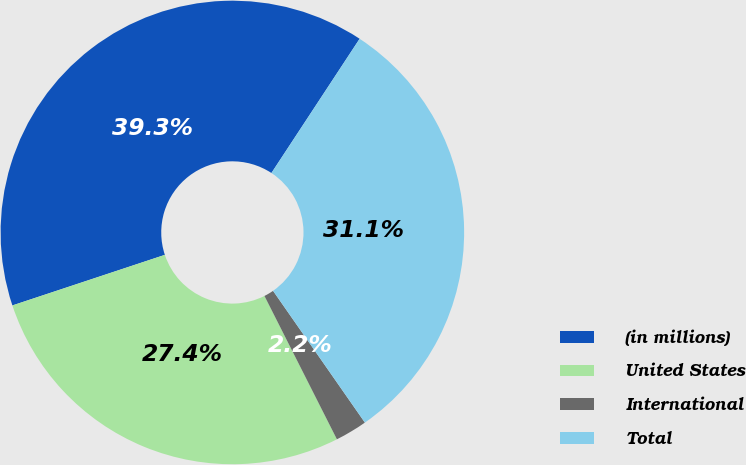Convert chart to OTSL. <chart><loc_0><loc_0><loc_500><loc_500><pie_chart><fcel>(in millions)<fcel>United States<fcel>International<fcel>Total<nl><fcel>39.35%<fcel>27.35%<fcel>2.24%<fcel>31.06%<nl></chart> 